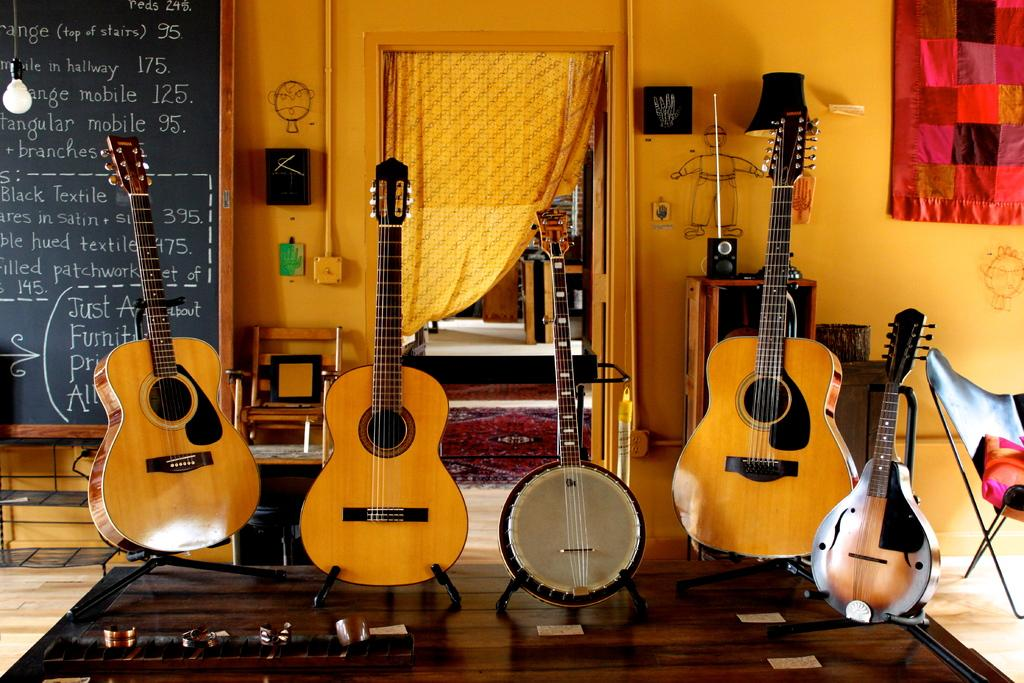What color is the wall that is visible in the image? There is an orange color wall in the image. What type of window treatment is present in the image? There is a curtain in the image. What is the color of the board that is visible in the image? There is a black color board in the image. What musical instruments are in the front of the image? There are guitars in the front of the image. What type of government is depicted on the orange wall in the image? There is no depiction of a government on the orange wall in the image; it is simply a wall with a color. Can you touch the coast in the image? There is no coast present in the image; it features an orange wall, a curtain, a black color board, and guitars. 